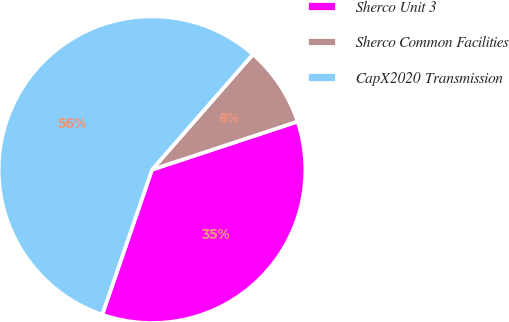<chart> <loc_0><loc_0><loc_500><loc_500><pie_chart><fcel>Sherco Unit 3<fcel>Sherco Common Facilities<fcel>CapX2020 Transmission<nl><fcel>35.34%<fcel>8.48%<fcel>56.17%<nl></chart> 